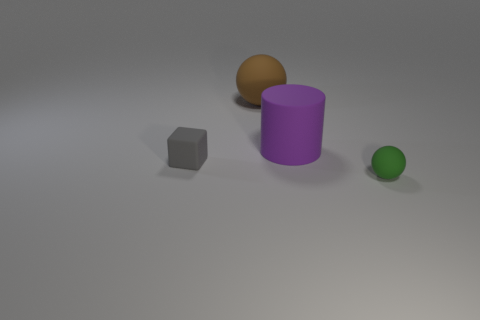Add 4 small balls. How many objects exist? 8 Add 2 rubber cylinders. How many rubber cylinders are left? 3 Add 1 big rubber spheres. How many big rubber spheres exist? 2 Subtract 1 green spheres. How many objects are left? 3 Subtract all cylinders. How many objects are left? 3 Subtract all brown cylinders. Subtract all cyan cubes. How many cylinders are left? 1 Subtract all purple balls. Subtract all small rubber things. How many objects are left? 2 